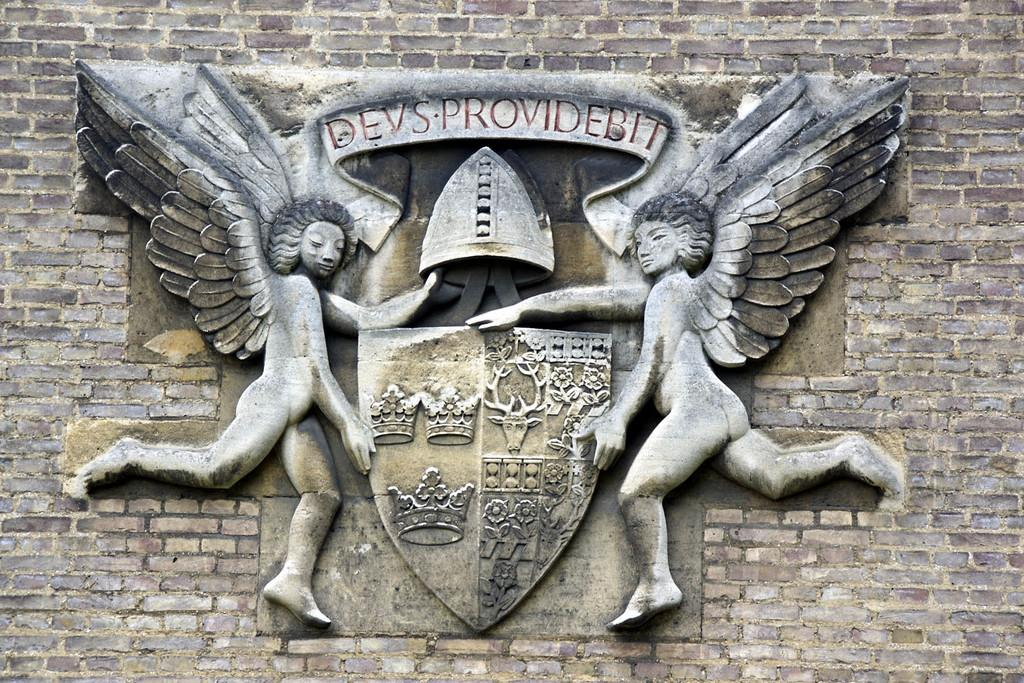What type of artwork is present in the image? There are sculptures in the image. What else can be seen on the wall in the image? There is text on the wall in the image. How much money is being pumped into the cent in the image? There is no money or cent present in the image; it only features sculptures and text on the wall. 